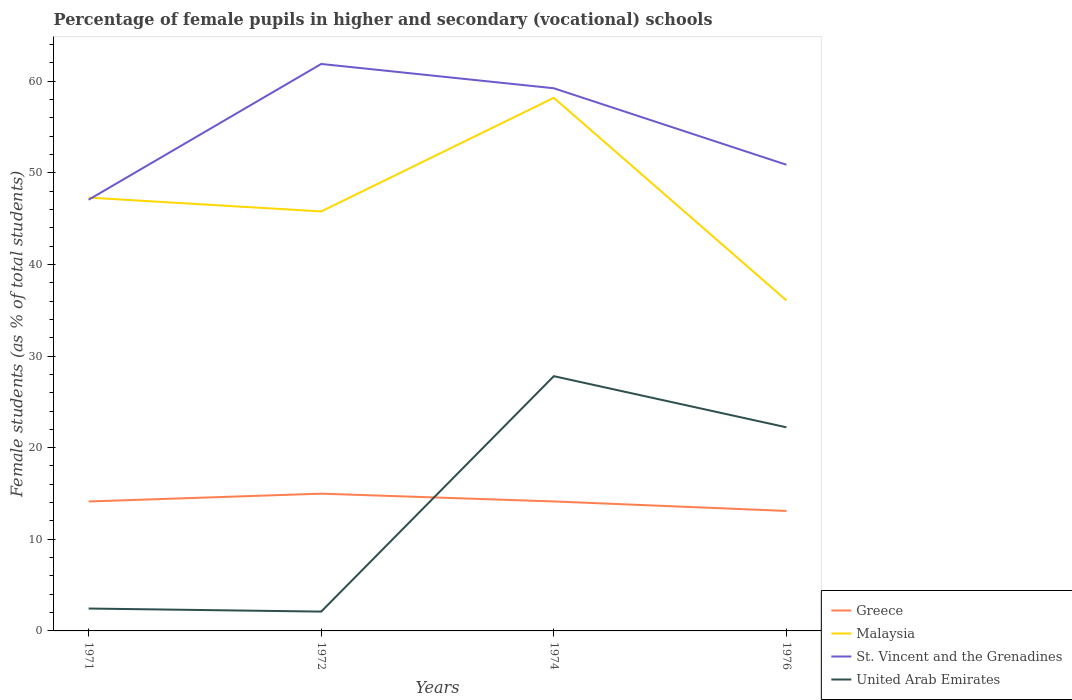How many different coloured lines are there?
Offer a very short reply. 4. Does the line corresponding to St. Vincent and the Grenadines intersect with the line corresponding to Greece?
Your answer should be very brief. No. Is the number of lines equal to the number of legend labels?
Your answer should be compact. Yes. Across all years, what is the maximum percentage of female pupils in higher and secondary schools in Malaysia?
Provide a succinct answer. 36.07. In which year was the percentage of female pupils in higher and secondary schools in St. Vincent and the Grenadines maximum?
Keep it short and to the point. 1971. What is the total percentage of female pupils in higher and secondary schools in Greece in the graph?
Give a very brief answer. -0.85. What is the difference between the highest and the second highest percentage of female pupils in higher and secondary schools in United Arab Emirates?
Make the answer very short. 25.69. What is the difference between the highest and the lowest percentage of female pupils in higher and secondary schools in Malaysia?
Make the answer very short. 2. Is the percentage of female pupils in higher and secondary schools in Greece strictly greater than the percentage of female pupils in higher and secondary schools in United Arab Emirates over the years?
Your answer should be compact. No. How many lines are there?
Offer a terse response. 4. What is the difference between two consecutive major ticks on the Y-axis?
Offer a terse response. 10. Where does the legend appear in the graph?
Your response must be concise. Bottom right. How are the legend labels stacked?
Your answer should be compact. Vertical. What is the title of the graph?
Ensure brevity in your answer.  Percentage of female pupils in higher and secondary (vocational) schools. What is the label or title of the Y-axis?
Your answer should be compact. Female students (as % of total students). What is the Female students (as % of total students) of Greece in 1971?
Make the answer very short. 14.13. What is the Female students (as % of total students) in Malaysia in 1971?
Keep it short and to the point. 47.29. What is the Female students (as % of total students) in St. Vincent and the Grenadines in 1971?
Provide a short and direct response. 47.06. What is the Female students (as % of total students) in United Arab Emirates in 1971?
Your answer should be very brief. 2.44. What is the Female students (as % of total students) in Greece in 1972?
Your answer should be very brief. 14.98. What is the Female students (as % of total students) of Malaysia in 1972?
Offer a terse response. 45.78. What is the Female students (as % of total students) of St. Vincent and the Grenadines in 1972?
Make the answer very short. 61.88. What is the Female students (as % of total students) of United Arab Emirates in 1972?
Offer a very short reply. 2.11. What is the Female students (as % of total students) in Greece in 1974?
Offer a terse response. 14.13. What is the Female students (as % of total students) in Malaysia in 1974?
Provide a short and direct response. 58.18. What is the Female students (as % of total students) of St. Vincent and the Grenadines in 1974?
Provide a succinct answer. 59.23. What is the Female students (as % of total students) of United Arab Emirates in 1974?
Offer a terse response. 27.8. What is the Female students (as % of total students) in Greece in 1976?
Provide a succinct answer. 13.09. What is the Female students (as % of total students) of Malaysia in 1976?
Offer a terse response. 36.07. What is the Female students (as % of total students) of St. Vincent and the Grenadines in 1976?
Offer a very short reply. 50.88. What is the Female students (as % of total students) in United Arab Emirates in 1976?
Provide a short and direct response. 22.22. Across all years, what is the maximum Female students (as % of total students) in Greece?
Ensure brevity in your answer.  14.98. Across all years, what is the maximum Female students (as % of total students) of Malaysia?
Your response must be concise. 58.18. Across all years, what is the maximum Female students (as % of total students) in St. Vincent and the Grenadines?
Offer a terse response. 61.88. Across all years, what is the maximum Female students (as % of total students) in United Arab Emirates?
Offer a very short reply. 27.8. Across all years, what is the minimum Female students (as % of total students) of Greece?
Your answer should be very brief. 13.09. Across all years, what is the minimum Female students (as % of total students) in Malaysia?
Make the answer very short. 36.07. Across all years, what is the minimum Female students (as % of total students) in St. Vincent and the Grenadines?
Your answer should be compact. 47.06. Across all years, what is the minimum Female students (as % of total students) in United Arab Emirates?
Offer a very short reply. 2.11. What is the total Female students (as % of total students) in Greece in the graph?
Ensure brevity in your answer.  56.34. What is the total Female students (as % of total students) of Malaysia in the graph?
Your response must be concise. 187.33. What is the total Female students (as % of total students) in St. Vincent and the Grenadines in the graph?
Provide a short and direct response. 219.04. What is the total Female students (as % of total students) in United Arab Emirates in the graph?
Ensure brevity in your answer.  54.58. What is the difference between the Female students (as % of total students) in Greece in 1971 and that in 1972?
Your response must be concise. -0.85. What is the difference between the Female students (as % of total students) in Malaysia in 1971 and that in 1972?
Offer a very short reply. 1.51. What is the difference between the Female students (as % of total students) in St. Vincent and the Grenadines in 1971 and that in 1972?
Your answer should be compact. -14.82. What is the difference between the Female students (as % of total students) in Greece in 1971 and that in 1974?
Make the answer very short. -0. What is the difference between the Female students (as % of total students) of Malaysia in 1971 and that in 1974?
Provide a short and direct response. -10.89. What is the difference between the Female students (as % of total students) of St. Vincent and the Grenadines in 1971 and that in 1974?
Offer a terse response. -12.17. What is the difference between the Female students (as % of total students) of United Arab Emirates in 1971 and that in 1974?
Offer a terse response. -25.36. What is the difference between the Female students (as % of total students) of Greece in 1971 and that in 1976?
Provide a short and direct response. 1.03. What is the difference between the Female students (as % of total students) of Malaysia in 1971 and that in 1976?
Provide a short and direct response. 11.22. What is the difference between the Female students (as % of total students) in St. Vincent and the Grenadines in 1971 and that in 1976?
Your response must be concise. -3.82. What is the difference between the Female students (as % of total students) of United Arab Emirates in 1971 and that in 1976?
Provide a short and direct response. -19.78. What is the difference between the Female students (as % of total students) in Greece in 1972 and that in 1974?
Keep it short and to the point. 0.85. What is the difference between the Female students (as % of total students) of Malaysia in 1972 and that in 1974?
Ensure brevity in your answer.  -12.4. What is the difference between the Female students (as % of total students) of St. Vincent and the Grenadines in 1972 and that in 1974?
Provide a short and direct response. 2.65. What is the difference between the Female students (as % of total students) of United Arab Emirates in 1972 and that in 1974?
Give a very brief answer. -25.69. What is the difference between the Female students (as % of total students) in Greece in 1972 and that in 1976?
Your answer should be compact. 1.89. What is the difference between the Female students (as % of total students) of Malaysia in 1972 and that in 1976?
Your answer should be compact. 9.71. What is the difference between the Female students (as % of total students) of St. Vincent and the Grenadines in 1972 and that in 1976?
Keep it short and to the point. 11. What is the difference between the Female students (as % of total students) in United Arab Emirates in 1972 and that in 1976?
Your answer should be very brief. -20.11. What is the difference between the Female students (as % of total students) in Greece in 1974 and that in 1976?
Your answer should be very brief. 1.04. What is the difference between the Female students (as % of total students) of Malaysia in 1974 and that in 1976?
Make the answer very short. 22.11. What is the difference between the Female students (as % of total students) of St. Vincent and the Grenadines in 1974 and that in 1976?
Provide a succinct answer. 8.35. What is the difference between the Female students (as % of total students) of United Arab Emirates in 1974 and that in 1976?
Your response must be concise. 5.58. What is the difference between the Female students (as % of total students) of Greece in 1971 and the Female students (as % of total students) of Malaysia in 1972?
Make the answer very short. -31.65. What is the difference between the Female students (as % of total students) in Greece in 1971 and the Female students (as % of total students) in St. Vincent and the Grenadines in 1972?
Offer a terse response. -47.75. What is the difference between the Female students (as % of total students) in Greece in 1971 and the Female students (as % of total students) in United Arab Emirates in 1972?
Offer a terse response. 12.02. What is the difference between the Female students (as % of total students) in Malaysia in 1971 and the Female students (as % of total students) in St. Vincent and the Grenadines in 1972?
Your answer should be very brief. -14.59. What is the difference between the Female students (as % of total students) of Malaysia in 1971 and the Female students (as % of total students) of United Arab Emirates in 1972?
Your response must be concise. 45.18. What is the difference between the Female students (as % of total students) of St. Vincent and the Grenadines in 1971 and the Female students (as % of total students) of United Arab Emirates in 1972?
Ensure brevity in your answer.  44.95. What is the difference between the Female students (as % of total students) in Greece in 1971 and the Female students (as % of total students) in Malaysia in 1974?
Provide a short and direct response. -44.05. What is the difference between the Female students (as % of total students) of Greece in 1971 and the Female students (as % of total students) of St. Vincent and the Grenadines in 1974?
Provide a short and direct response. -45.1. What is the difference between the Female students (as % of total students) in Greece in 1971 and the Female students (as % of total students) in United Arab Emirates in 1974?
Offer a terse response. -13.67. What is the difference between the Female students (as % of total students) of Malaysia in 1971 and the Female students (as % of total students) of St. Vincent and the Grenadines in 1974?
Make the answer very short. -11.93. What is the difference between the Female students (as % of total students) of Malaysia in 1971 and the Female students (as % of total students) of United Arab Emirates in 1974?
Offer a terse response. 19.49. What is the difference between the Female students (as % of total students) in St. Vincent and the Grenadines in 1971 and the Female students (as % of total students) in United Arab Emirates in 1974?
Provide a succinct answer. 19.26. What is the difference between the Female students (as % of total students) in Greece in 1971 and the Female students (as % of total students) in Malaysia in 1976?
Ensure brevity in your answer.  -21.94. What is the difference between the Female students (as % of total students) in Greece in 1971 and the Female students (as % of total students) in St. Vincent and the Grenadines in 1976?
Provide a succinct answer. -36.75. What is the difference between the Female students (as % of total students) in Greece in 1971 and the Female students (as % of total students) in United Arab Emirates in 1976?
Make the answer very short. -8.09. What is the difference between the Female students (as % of total students) of Malaysia in 1971 and the Female students (as % of total students) of St. Vincent and the Grenadines in 1976?
Give a very brief answer. -3.58. What is the difference between the Female students (as % of total students) of Malaysia in 1971 and the Female students (as % of total students) of United Arab Emirates in 1976?
Provide a succinct answer. 25.07. What is the difference between the Female students (as % of total students) in St. Vincent and the Grenadines in 1971 and the Female students (as % of total students) in United Arab Emirates in 1976?
Give a very brief answer. 24.84. What is the difference between the Female students (as % of total students) in Greece in 1972 and the Female students (as % of total students) in Malaysia in 1974?
Ensure brevity in your answer.  -43.2. What is the difference between the Female students (as % of total students) in Greece in 1972 and the Female students (as % of total students) in St. Vincent and the Grenadines in 1974?
Your answer should be very brief. -44.25. What is the difference between the Female students (as % of total students) of Greece in 1972 and the Female students (as % of total students) of United Arab Emirates in 1974?
Ensure brevity in your answer.  -12.82. What is the difference between the Female students (as % of total students) in Malaysia in 1972 and the Female students (as % of total students) in St. Vincent and the Grenadines in 1974?
Give a very brief answer. -13.44. What is the difference between the Female students (as % of total students) of Malaysia in 1972 and the Female students (as % of total students) of United Arab Emirates in 1974?
Offer a very short reply. 17.98. What is the difference between the Female students (as % of total students) of St. Vincent and the Grenadines in 1972 and the Female students (as % of total students) of United Arab Emirates in 1974?
Give a very brief answer. 34.07. What is the difference between the Female students (as % of total students) of Greece in 1972 and the Female students (as % of total students) of Malaysia in 1976?
Make the answer very short. -21.09. What is the difference between the Female students (as % of total students) in Greece in 1972 and the Female students (as % of total students) in St. Vincent and the Grenadines in 1976?
Provide a short and direct response. -35.9. What is the difference between the Female students (as % of total students) in Greece in 1972 and the Female students (as % of total students) in United Arab Emirates in 1976?
Your answer should be very brief. -7.24. What is the difference between the Female students (as % of total students) of Malaysia in 1972 and the Female students (as % of total students) of St. Vincent and the Grenadines in 1976?
Offer a very short reply. -5.1. What is the difference between the Female students (as % of total students) of Malaysia in 1972 and the Female students (as % of total students) of United Arab Emirates in 1976?
Keep it short and to the point. 23.56. What is the difference between the Female students (as % of total students) of St. Vincent and the Grenadines in 1972 and the Female students (as % of total students) of United Arab Emirates in 1976?
Ensure brevity in your answer.  39.66. What is the difference between the Female students (as % of total students) of Greece in 1974 and the Female students (as % of total students) of Malaysia in 1976?
Your response must be concise. -21.94. What is the difference between the Female students (as % of total students) in Greece in 1974 and the Female students (as % of total students) in St. Vincent and the Grenadines in 1976?
Your response must be concise. -36.75. What is the difference between the Female students (as % of total students) of Greece in 1974 and the Female students (as % of total students) of United Arab Emirates in 1976?
Keep it short and to the point. -8.09. What is the difference between the Female students (as % of total students) in Malaysia in 1974 and the Female students (as % of total students) in St. Vincent and the Grenadines in 1976?
Your answer should be compact. 7.31. What is the difference between the Female students (as % of total students) of Malaysia in 1974 and the Female students (as % of total students) of United Arab Emirates in 1976?
Provide a succinct answer. 35.96. What is the difference between the Female students (as % of total students) in St. Vincent and the Grenadines in 1974 and the Female students (as % of total students) in United Arab Emirates in 1976?
Provide a succinct answer. 37. What is the average Female students (as % of total students) in Greece per year?
Provide a short and direct response. 14.08. What is the average Female students (as % of total students) of Malaysia per year?
Offer a terse response. 46.83. What is the average Female students (as % of total students) of St. Vincent and the Grenadines per year?
Provide a succinct answer. 54.76. What is the average Female students (as % of total students) in United Arab Emirates per year?
Ensure brevity in your answer.  13.64. In the year 1971, what is the difference between the Female students (as % of total students) in Greece and Female students (as % of total students) in Malaysia?
Your answer should be compact. -33.16. In the year 1971, what is the difference between the Female students (as % of total students) in Greece and Female students (as % of total students) in St. Vincent and the Grenadines?
Offer a terse response. -32.93. In the year 1971, what is the difference between the Female students (as % of total students) of Greece and Female students (as % of total students) of United Arab Emirates?
Offer a very short reply. 11.69. In the year 1971, what is the difference between the Female students (as % of total students) in Malaysia and Female students (as % of total students) in St. Vincent and the Grenadines?
Give a very brief answer. 0.23. In the year 1971, what is the difference between the Female students (as % of total students) in Malaysia and Female students (as % of total students) in United Arab Emirates?
Keep it short and to the point. 44.85. In the year 1971, what is the difference between the Female students (as % of total students) of St. Vincent and the Grenadines and Female students (as % of total students) of United Arab Emirates?
Ensure brevity in your answer.  44.62. In the year 1972, what is the difference between the Female students (as % of total students) in Greece and Female students (as % of total students) in Malaysia?
Give a very brief answer. -30.8. In the year 1972, what is the difference between the Female students (as % of total students) in Greece and Female students (as % of total students) in St. Vincent and the Grenadines?
Offer a terse response. -46.9. In the year 1972, what is the difference between the Female students (as % of total students) of Greece and Female students (as % of total students) of United Arab Emirates?
Offer a very short reply. 12.87. In the year 1972, what is the difference between the Female students (as % of total students) of Malaysia and Female students (as % of total students) of St. Vincent and the Grenadines?
Offer a terse response. -16.1. In the year 1972, what is the difference between the Female students (as % of total students) in Malaysia and Female students (as % of total students) in United Arab Emirates?
Provide a succinct answer. 43.67. In the year 1972, what is the difference between the Female students (as % of total students) in St. Vincent and the Grenadines and Female students (as % of total students) in United Arab Emirates?
Keep it short and to the point. 59.77. In the year 1974, what is the difference between the Female students (as % of total students) in Greece and Female students (as % of total students) in Malaysia?
Your response must be concise. -44.05. In the year 1974, what is the difference between the Female students (as % of total students) in Greece and Female students (as % of total students) in St. Vincent and the Grenadines?
Your response must be concise. -45.09. In the year 1974, what is the difference between the Female students (as % of total students) in Greece and Female students (as % of total students) in United Arab Emirates?
Your response must be concise. -13.67. In the year 1974, what is the difference between the Female students (as % of total students) in Malaysia and Female students (as % of total students) in St. Vincent and the Grenadines?
Provide a short and direct response. -1.04. In the year 1974, what is the difference between the Female students (as % of total students) of Malaysia and Female students (as % of total students) of United Arab Emirates?
Ensure brevity in your answer.  30.38. In the year 1974, what is the difference between the Female students (as % of total students) of St. Vincent and the Grenadines and Female students (as % of total students) of United Arab Emirates?
Your answer should be compact. 31.42. In the year 1976, what is the difference between the Female students (as % of total students) of Greece and Female students (as % of total students) of Malaysia?
Your response must be concise. -22.98. In the year 1976, what is the difference between the Female students (as % of total students) in Greece and Female students (as % of total students) in St. Vincent and the Grenadines?
Your response must be concise. -37.78. In the year 1976, what is the difference between the Female students (as % of total students) in Greece and Female students (as % of total students) in United Arab Emirates?
Make the answer very short. -9.13. In the year 1976, what is the difference between the Female students (as % of total students) of Malaysia and Female students (as % of total students) of St. Vincent and the Grenadines?
Make the answer very short. -14.81. In the year 1976, what is the difference between the Female students (as % of total students) of Malaysia and Female students (as % of total students) of United Arab Emirates?
Give a very brief answer. 13.85. In the year 1976, what is the difference between the Female students (as % of total students) in St. Vincent and the Grenadines and Female students (as % of total students) in United Arab Emirates?
Your answer should be compact. 28.66. What is the ratio of the Female students (as % of total students) in Greece in 1971 to that in 1972?
Make the answer very short. 0.94. What is the ratio of the Female students (as % of total students) in Malaysia in 1971 to that in 1972?
Your response must be concise. 1.03. What is the ratio of the Female students (as % of total students) of St. Vincent and the Grenadines in 1971 to that in 1972?
Your response must be concise. 0.76. What is the ratio of the Female students (as % of total students) in United Arab Emirates in 1971 to that in 1972?
Offer a very short reply. 1.16. What is the ratio of the Female students (as % of total students) in Greece in 1971 to that in 1974?
Provide a short and direct response. 1. What is the ratio of the Female students (as % of total students) in Malaysia in 1971 to that in 1974?
Make the answer very short. 0.81. What is the ratio of the Female students (as % of total students) in St. Vincent and the Grenadines in 1971 to that in 1974?
Your answer should be very brief. 0.79. What is the ratio of the Female students (as % of total students) of United Arab Emirates in 1971 to that in 1974?
Provide a short and direct response. 0.09. What is the ratio of the Female students (as % of total students) of Greece in 1971 to that in 1976?
Offer a very short reply. 1.08. What is the ratio of the Female students (as % of total students) of Malaysia in 1971 to that in 1976?
Provide a succinct answer. 1.31. What is the ratio of the Female students (as % of total students) of St. Vincent and the Grenadines in 1971 to that in 1976?
Provide a short and direct response. 0.92. What is the ratio of the Female students (as % of total students) of United Arab Emirates in 1971 to that in 1976?
Provide a succinct answer. 0.11. What is the ratio of the Female students (as % of total students) of Greece in 1972 to that in 1974?
Provide a short and direct response. 1.06. What is the ratio of the Female students (as % of total students) of Malaysia in 1972 to that in 1974?
Ensure brevity in your answer.  0.79. What is the ratio of the Female students (as % of total students) of St. Vincent and the Grenadines in 1972 to that in 1974?
Keep it short and to the point. 1.04. What is the ratio of the Female students (as % of total students) of United Arab Emirates in 1972 to that in 1974?
Give a very brief answer. 0.08. What is the ratio of the Female students (as % of total students) of Greece in 1972 to that in 1976?
Offer a terse response. 1.14. What is the ratio of the Female students (as % of total students) in Malaysia in 1972 to that in 1976?
Provide a short and direct response. 1.27. What is the ratio of the Female students (as % of total students) in St. Vincent and the Grenadines in 1972 to that in 1976?
Your answer should be very brief. 1.22. What is the ratio of the Female students (as % of total students) of United Arab Emirates in 1972 to that in 1976?
Offer a terse response. 0.09. What is the ratio of the Female students (as % of total students) in Greece in 1974 to that in 1976?
Keep it short and to the point. 1.08. What is the ratio of the Female students (as % of total students) in Malaysia in 1974 to that in 1976?
Ensure brevity in your answer.  1.61. What is the ratio of the Female students (as % of total students) of St. Vincent and the Grenadines in 1974 to that in 1976?
Your answer should be very brief. 1.16. What is the ratio of the Female students (as % of total students) of United Arab Emirates in 1974 to that in 1976?
Provide a succinct answer. 1.25. What is the difference between the highest and the second highest Female students (as % of total students) of Greece?
Provide a short and direct response. 0.85. What is the difference between the highest and the second highest Female students (as % of total students) of Malaysia?
Offer a very short reply. 10.89. What is the difference between the highest and the second highest Female students (as % of total students) in St. Vincent and the Grenadines?
Provide a short and direct response. 2.65. What is the difference between the highest and the second highest Female students (as % of total students) in United Arab Emirates?
Give a very brief answer. 5.58. What is the difference between the highest and the lowest Female students (as % of total students) in Greece?
Your answer should be very brief. 1.89. What is the difference between the highest and the lowest Female students (as % of total students) in Malaysia?
Your response must be concise. 22.11. What is the difference between the highest and the lowest Female students (as % of total students) of St. Vincent and the Grenadines?
Make the answer very short. 14.82. What is the difference between the highest and the lowest Female students (as % of total students) of United Arab Emirates?
Your response must be concise. 25.69. 